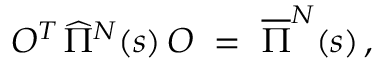Convert formula to latex. <formula><loc_0><loc_0><loc_500><loc_500>O ^ { T } \, \widehat { \Pi } ^ { N } ( s ) \, O \ = \ \overline { \Pi } ^ { N } ( s ) \, ,</formula> 